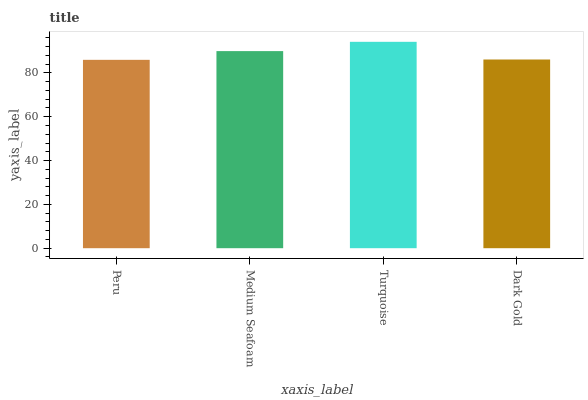Is Peru the minimum?
Answer yes or no. Yes. Is Turquoise the maximum?
Answer yes or no. Yes. Is Medium Seafoam the minimum?
Answer yes or no. No. Is Medium Seafoam the maximum?
Answer yes or no. No. Is Medium Seafoam greater than Peru?
Answer yes or no. Yes. Is Peru less than Medium Seafoam?
Answer yes or no. Yes. Is Peru greater than Medium Seafoam?
Answer yes or no. No. Is Medium Seafoam less than Peru?
Answer yes or no. No. Is Medium Seafoam the high median?
Answer yes or no. Yes. Is Dark Gold the low median?
Answer yes or no. Yes. Is Dark Gold the high median?
Answer yes or no. No. Is Medium Seafoam the low median?
Answer yes or no. No. 